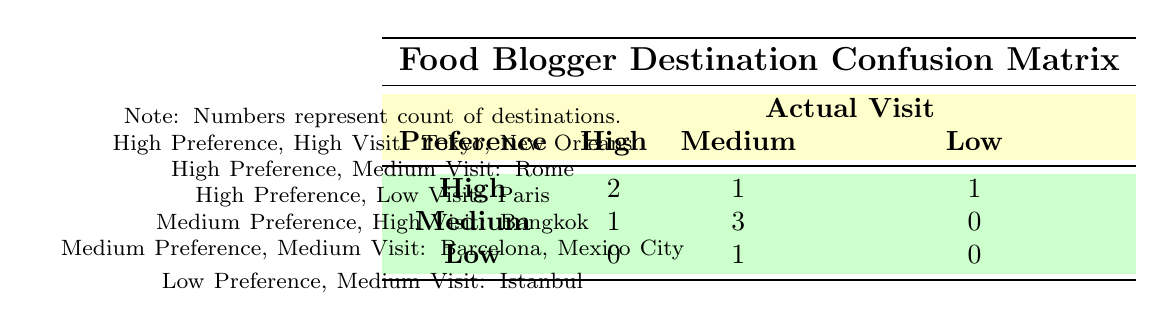What is the number of destinations with a high preference and high actual visit? Looking at the table, we find that there are two instances where the preference is high and the actual visit is also high: Tokyo, Japan, and New Orleans, USA. Counting these gives us a total of 2.
Answer: 2 How many destinations are there with medium preference and medium actual visit? By checking the table, we see there are two cases where the preference and the actual visits are both medium: Barcelona, Spain, and Mexico City, Mexico. Adding these gives us a total of 2.
Answer: 2 Is there any destination that has a low preference and a high actual visit? Referring to the table, there are no locations listed with a low preference and a high actual visit. All relevant categories show either medium or high combinations. Therefore, this statement is false.
Answer: No What is the total count of destinations that have a high preference? The table lists four destinations under high preference: Tokyo, Rome, Paris, and New Orleans. Counting these up gives a total of 4 destinations.
Answer: 4 How many total destinations had an actual visit that was lower than high? From the table, we can see the following counts for actual visits less than high: There is one low visit (Paris) and three medium visits (Rome, Istanbul, and Mexico City). Adding these up results in a total of 4.
Answer: 4 Are there more destinations with a high preference or medium preference? Looking closely at the table, we note there are 4 destinations with high preference (Tokyo, Rome, Paris, New Orleans) and 4 destinations with medium preference (Bangkok, Barcelona, Mexico City, Istanbul). Since both counts are equal, the answer is no.
Answer: No How many destinations had a high preference but only a medium actual visit? The table shows that only one destination fits this criterion: Rome, Italy, which has a high preference and a medium actual visit. Thus, the count is straightforward: 1.
Answer: 1 What is the sum of high and medium visits across all destination preferences? The high visits total from the table is 4 (two from high preference and one each from medium preference) and the medium visits total is 5 (one high, three medium, and one low preference), so adding these together gives us 4 + 5 = 9.
Answer: 9 